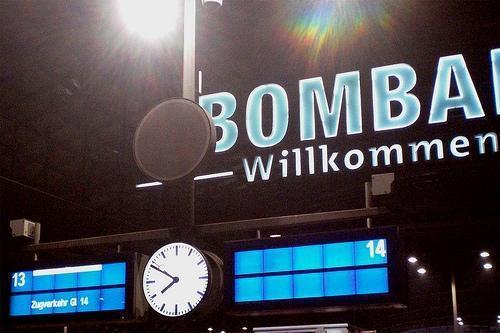How many clocks are visible?
Give a very brief answer. 1. How many empty blue squares are there?
Give a very brief answer. 12. 